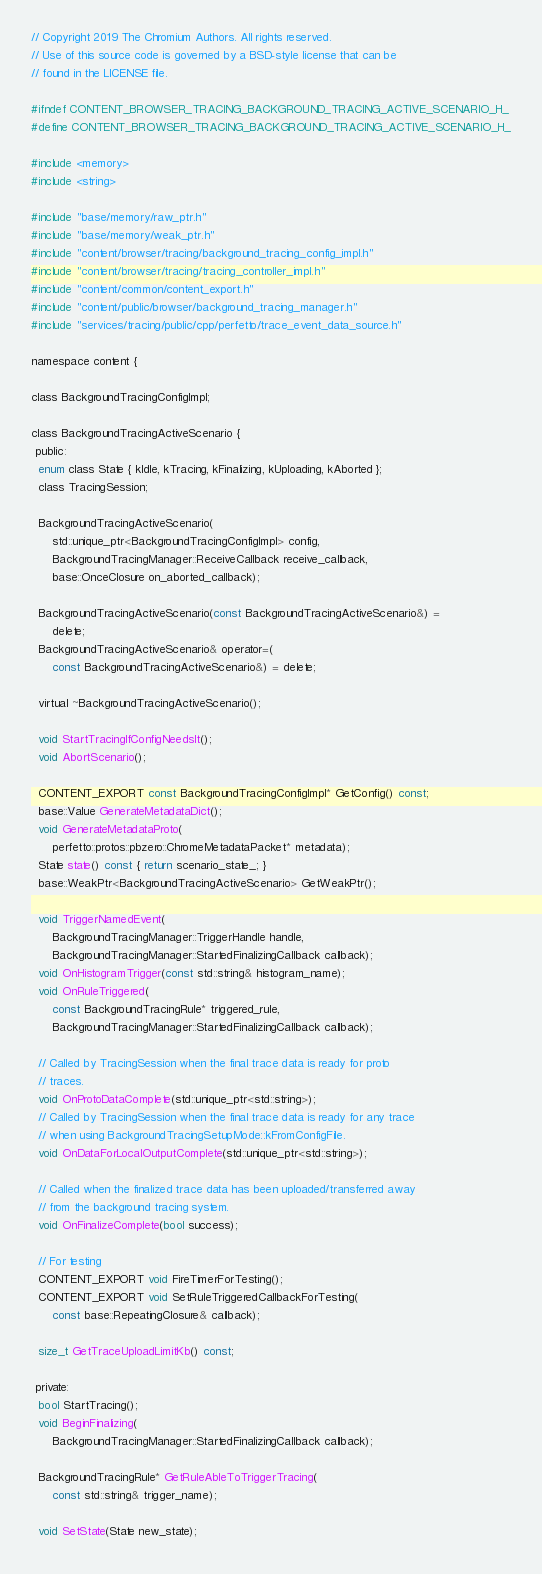Convert code to text. <code><loc_0><loc_0><loc_500><loc_500><_C_>// Copyright 2019 The Chromium Authors. All rights reserved.
// Use of this source code is governed by a BSD-style license that can be
// found in the LICENSE file.

#ifndef CONTENT_BROWSER_TRACING_BACKGROUND_TRACING_ACTIVE_SCENARIO_H_
#define CONTENT_BROWSER_TRACING_BACKGROUND_TRACING_ACTIVE_SCENARIO_H_

#include <memory>
#include <string>

#include "base/memory/raw_ptr.h"
#include "base/memory/weak_ptr.h"
#include "content/browser/tracing/background_tracing_config_impl.h"
#include "content/browser/tracing/tracing_controller_impl.h"
#include "content/common/content_export.h"
#include "content/public/browser/background_tracing_manager.h"
#include "services/tracing/public/cpp/perfetto/trace_event_data_source.h"

namespace content {

class BackgroundTracingConfigImpl;

class BackgroundTracingActiveScenario {
 public:
  enum class State { kIdle, kTracing, kFinalizing, kUploading, kAborted };
  class TracingSession;

  BackgroundTracingActiveScenario(
      std::unique_ptr<BackgroundTracingConfigImpl> config,
      BackgroundTracingManager::ReceiveCallback receive_callback,
      base::OnceClosure on_aborted_callback);

  BackgroundTracingActiveScenario(const BackgroundTracingActiveScenario&) =
      delete;
  BackgroundTracingActiveScenario& operator=(
      const BackgroundTracingActiveScenario&) = delete;

  virtual ~BackgroundTracingActiveScenario();

  void StartTracingIfConfigNeedsIt();
  void AbortScenario();

  CONTENT_EXPORT const BackgroundTracingConfigImpl* GetConfig() const;
  base::Value GenerateMetadataDict();
  void GenerateMetadataProto(
      perfetto::protos::pbzero::ChromeMetadataPacket* metadata);
  State state() const { return scenario_state_; }
  base::WeakPtr<BackgroundTracingActiveScenario> GetWeakPtr();

  void TriggerNamedEvent(
      BackgroundTracingManager::TriggerHandle handle,
      BackgroundTracingManager::StartedFinalizingCallback callback);
  void OnHistogramTrigger(const std::string& histogram_name);
  void OnRuleTriggered(
      const BackgroundTracingRule* triggered_rule,
      BackgroundTracingManager::StartedFinalizingCallback callback);

  // Called by TracingSession when the final trace data is ready for proto
  // traces.
  void OnProtoDataComplete(std::unique_ptr<std::string>);
  // Called by TracingSession when the final trace data is ready for any trace
  // when using BackgroundTracingSetupMode::kFromConfigFile.
  void OnDataForLocalOutputComplete(std::unique_ptr<std::string>);

  // Called when the finalized trace data has been uploaded/transferred away
  // from the background tracing system.
  void OnFinalizeComplete(bool success);

  // For testing
  CONTENT_EXPORT void FireTimerForTesting();
  CONTENT_EXPORT void SetRuleTriggeredCallbackForTesting(
      const base::RepeatingClosure& callback);

  size_t GetTraceUploadLimitKb() const;

 private:
  bool StartTracing();
  void BeginFinalizing(
      BackgroundTracingManager::StartedFinalizingCallback callback);

  BackgroundTracingRule* GetRuleAbleToTriggerTracing(
      const std::string& trigger_name);

  void SetState(State new_state);
</code> 